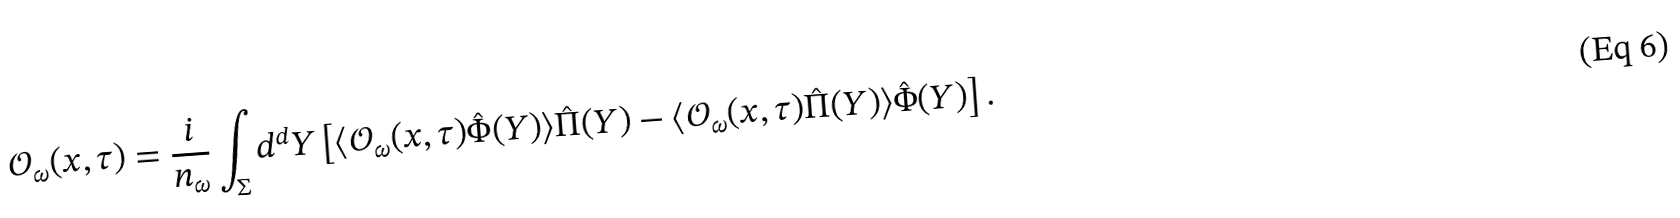<formula> <loc_0><loc_0><loc_500><loc_500>\mathcal { O } _ { \omega } ( x , \tau ) = \frac { i } { n _ { \omega } } \int _ { \Sigma } d ^ { d } Y \left [ \langle \mathcal { O } _ { \omega } ( x , \tau ) \hat { \Phi } ( Y ) \rangle \hat { \Pi } ( Y ) - \langle \mathcal { O } _ { \omega } ( x , \tau ) \hat { \Pi } ( Y ) \rangle \hat { \Phi } ( Y ) \right ] .</formula> 